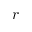Convert formula to latex. <formula><loc_0><loc_0><loc_500><loc_500>r</formula> 